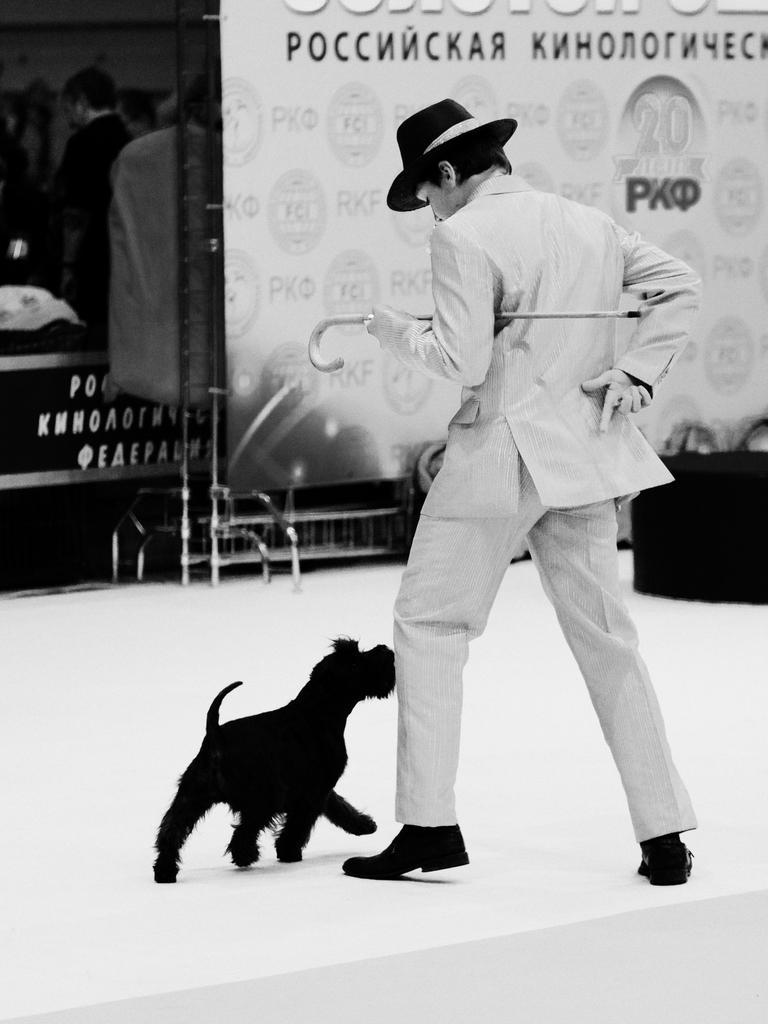How would you summarize this image in a sentence or two? In this picture there is a man and a dog. The man is holding a stick in his hands. 